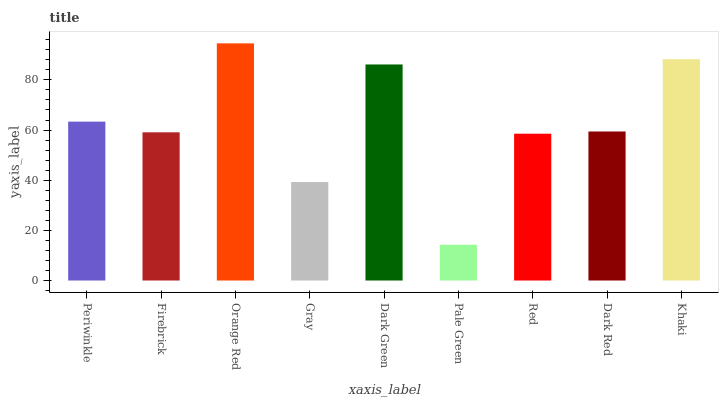Is Firebrick the minimum?
Answer yes or no. No. Is Firebrick the maximum?
Answer yes or no. No. Is Periwinkle greater than Firebrick?
Answer yes or no. Yes. Is Firebrick less than Periwinkle?
Answer yes or no. Yes. Is Firebrick greater than Periwinkle?
Answer yes or no. No. Is Periwinkle less than Firebrick?
Answer yes or no. No. Is Dark Red the high median?
Answer yes or no. Yes. Is Dark Red the low median?
Answer yes or no. Yes. Is Periwinkle the high median?
Answer yes or no. No. Is Dark Green the low median?
Answer yes or no. No. 